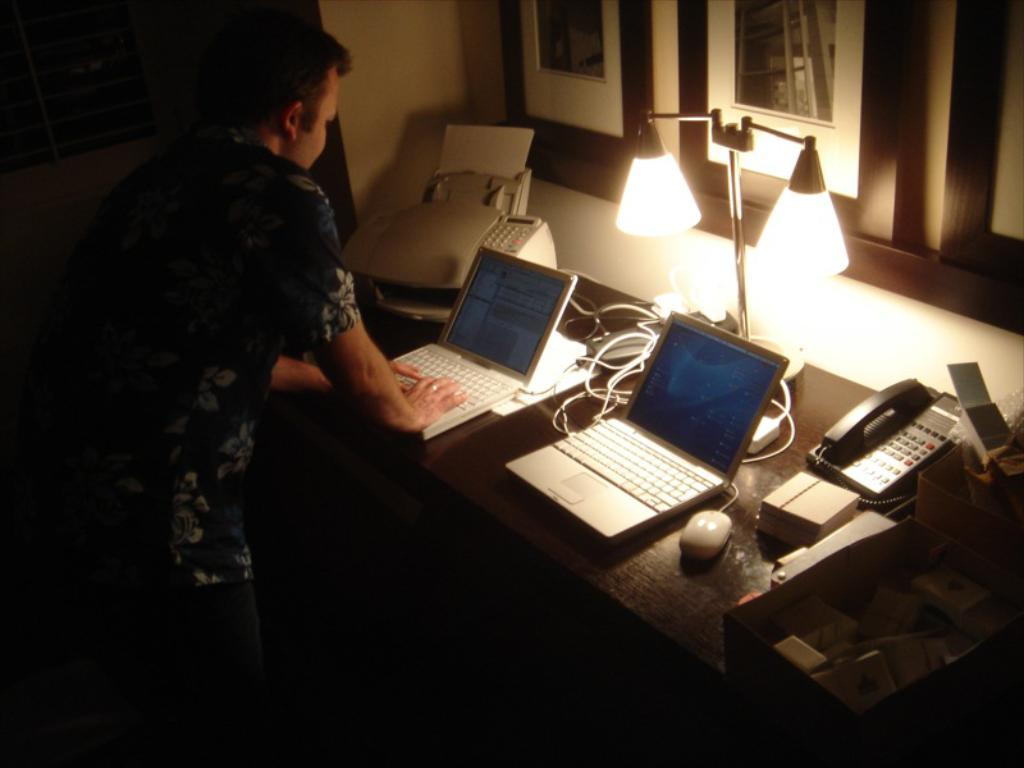What is the main subject of the image? There is a man standing in the image. What electronic devices can be seen in the image? There are at least two laptops, a telephone, and a printer in the image. Where are these objects located? All of these objects are on a table. What type of fuel is being used by the church in the image? There is no church present in the image, so it is not possible to determine what type of fuel it might be using. 